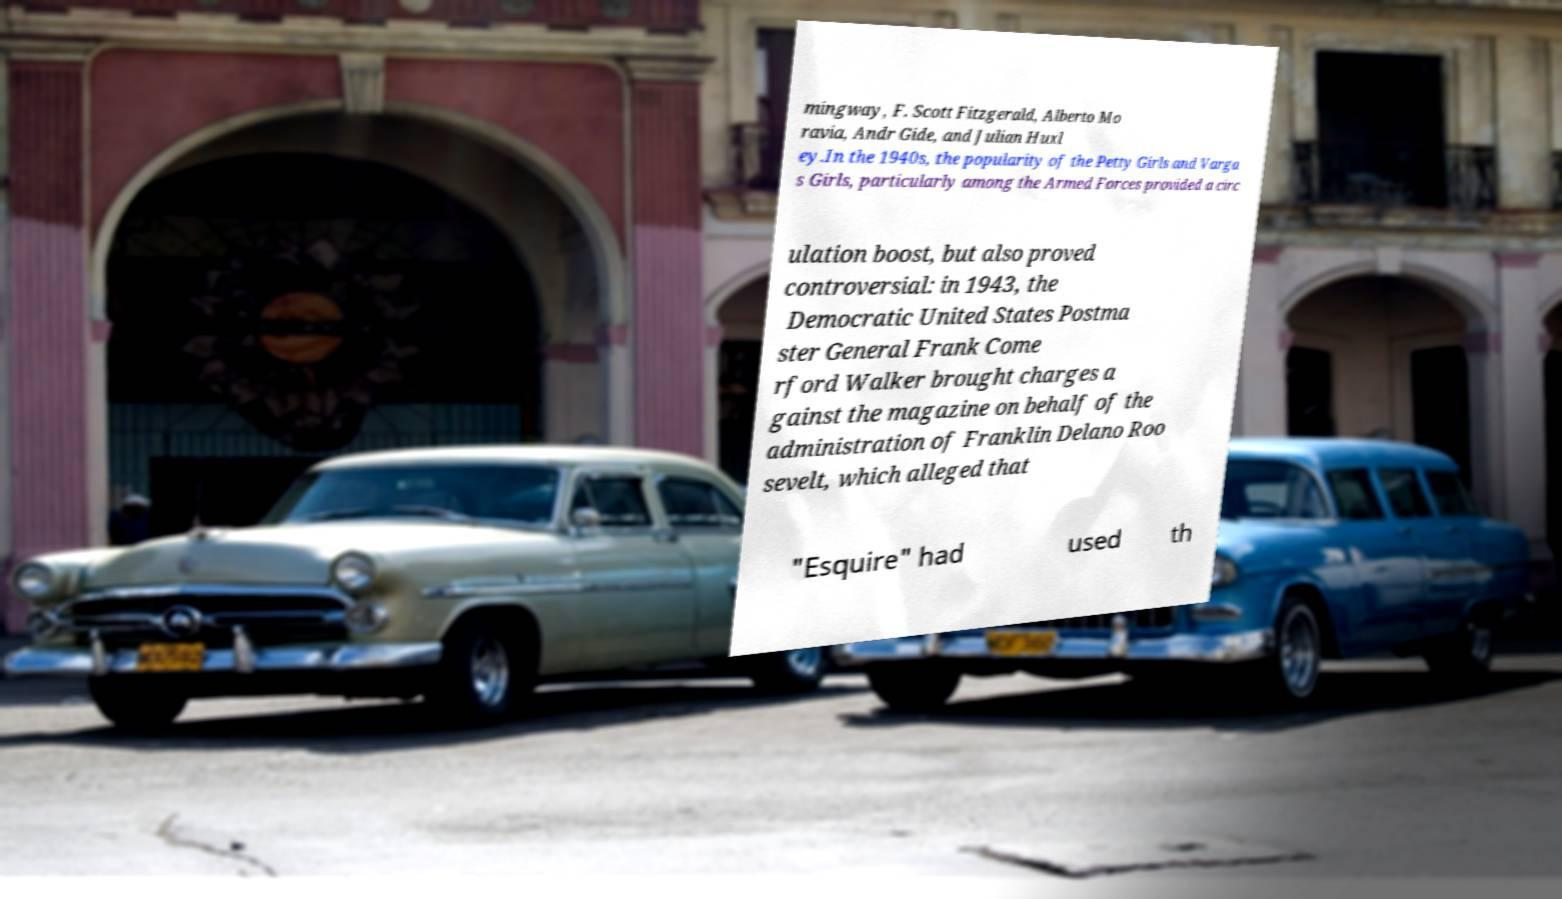Can you read and provide the text displayed in the image?This photo seems to have some interesting text. Can you extract and type it out for me? mingway, F. Scott Fitzgerald, Alberto Mo ravia, Andr Gide, and Julian Huxl ey.In the 1940s, the popularity of the Petty Girls and Varga s Girls, particularly among the Armed Forces provided a circ ulation boost, but also proved controversial: in 1943, the Democratic United States Postma ster General Frank Come rford Walker brought charges a gainst the magazine on behalf of the administration of Franklin Delano Roo sevelt, which alleged that "Esquire" had used th 